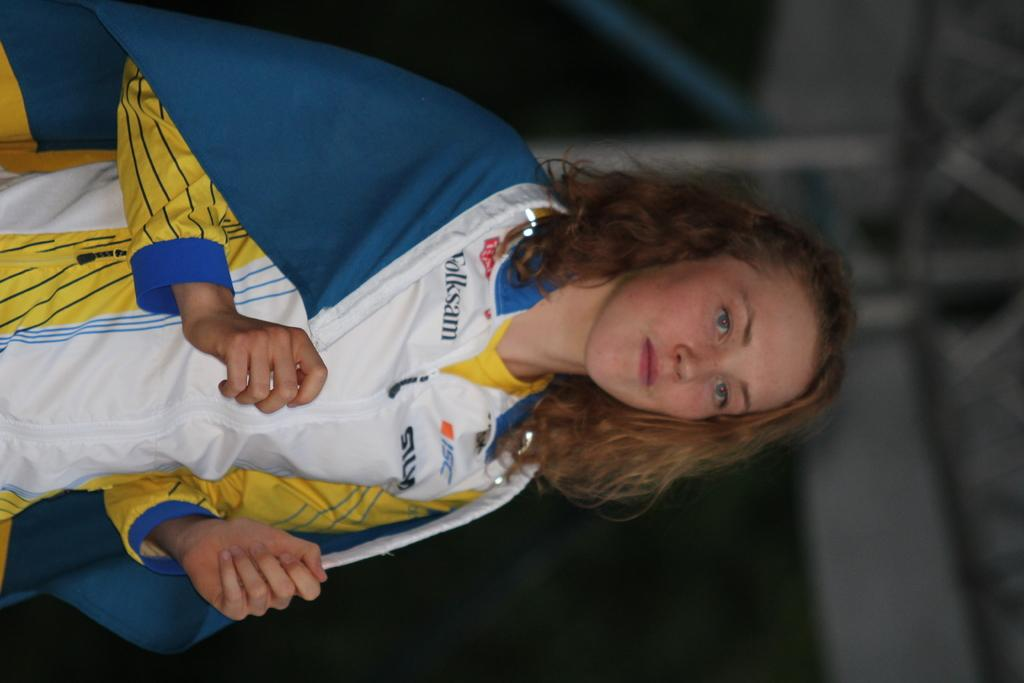<image>
Relay a brief, clear account of the picture shown. A women wearing a white and yellow shirt with ISC on it. 